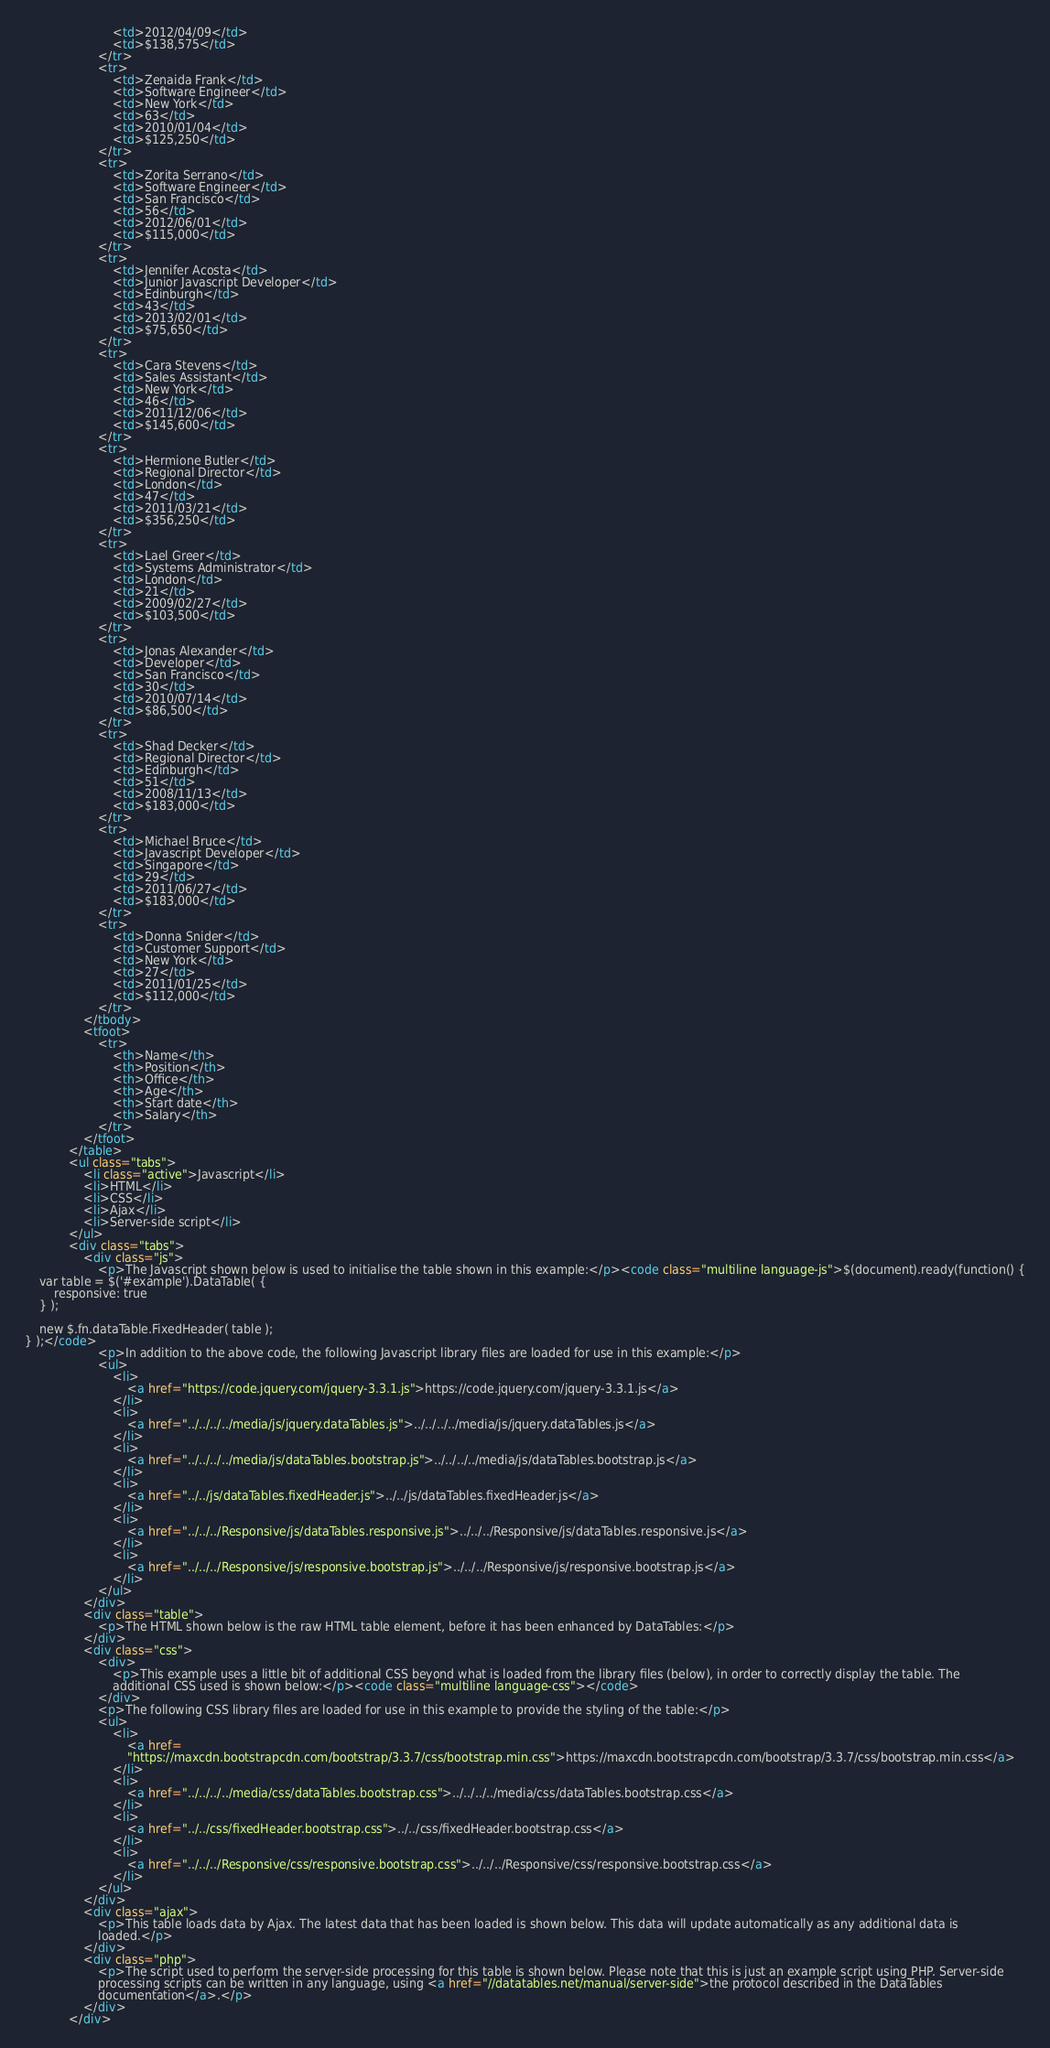<code> <loc_0><loc_0><loc_500><loc_500><_HTML_>						<td>2012/04/09</td>
						<td>$138,575</td>
					</tr>
					<tr>
						<td>Zenaida Frank</td>
						<td>Software Engineer</td>
						<td>New York</td>
						<td>63</td>
						<td>2010/01/04</td>
						<td>$125,250</td>
					</tr>
					<tr>
						<td>Zorita Serrano</td>
						<td>Software Engineer</td>
						<td>San Francisco</td>
						<td>56</td>
						<td>2012/06/01</td>
						<td>$115,000</td>
					</tr>
					<tr>
						<td>Jennifer Acosta</td>
						<td>Junior Javascript Developer</td>
						<td>Edinburgh</td>
						<td>43</td>
						<td>2013/02/01</td>
						<td>$75,650</td>
					</tr>
					<tr>
						<td>Cara Stevens</td>
						<td>Sales Assistant</td>
						<td>New York</td>
						<td>46</td>
						<td>2011/12/06</td>
						<td>$145,600</td>
					</tr>
					<tr>
						<td>Hermione Butler</td>
						<td>Regional Director</td>
						<td>London</td>
						<td>47</td>
						<td>2011/03/21</td>
						<td>$356,250</td>
					</tr>
					<tr>
						<td>Lael Greer</td>
						<td>Systems Administrator</td>
						<td>London</td>
						<td>21</td>
						<td>2009/02/27</td>
						<td>$103,500</td>
					</tr>
					<tr>
						<td>Jonas Alexander</td>
						<td>Developer</td>
						<td>San Francisco</td>
						<td>30</td>
						<td>2010/07/14</td>
						<td>$86,500</td>
					</tr>
					<tr>
						<td>Shad Decker</td>
						<td>Regional Director</td>
						<td>Edinburgh</td>
						<td>51</td>
						<td>2008/11/13</td>
						<td>$183,000</td>
					</tr>
					<tr>
						<td>Michael Bruce</td>
						<td>Javascript Developer</td>
						<td>Singapore</td>
						<td>29</td>
						<td>2011/06/27</td>
						<td>$183,000</td>
					</tr>
					<tr>
						<td>Donna Snider</td>
						<td>Customer Support</td>
						<td>New York</td>
						<td>27</td>
						<td>2011/01/25</td>
						<td>$112,000</td>
					</tr>
				</tbody>
				<tfoot>
					<tr>
						<th>Name</th>
						<th>Position</th>
						<th>Office</th>
						<th>Age</th>
						<th>Start date</th>
						<th>Salary</th>
					</tr>
				</tfoot>
			</table>
			<ul class="tabs">
				<li class="active">Javascript</li>
				<li>HTML</li>
				<li>CSS</li>
				<li>Ajax</li>
				<li>Server-side script</li>
			</ul>
			<div class="tabs">
				<div class="js">
					<p>The Javascript shown below is used to initialise the table shown in this example:</p><code class="multiline language-js">$(document).ready(function() {
	var table = $('#example').DataTable( {
		responsive: true
	} );

	new $.fn.dataTable.FixedHeader( table );
} );</code>
					<p>In addition to the above code, the following Javascript library files are loaded for use in this example:</p>
					<ul>
						<li>
							<a href="https://code.jquery.com/jquery-3.3.1.js">https://code.jquery.com/jquery-3.3.1.js</a>
						</li>
						<li>
							<a href="../../../../media/js/jquery.dataTables.js">../../../../media/js/jquery.dataTables.js</a>
						</li>
						<li>
							<a href="../../../../media/js/dataTables.bootstrap.js">../../../../media/js/dataTables.bootstrap.js</a>
						</li>
						<li>
							<a href="../../js/dataTables.fixedHeader.js">../../js/dataTables.fixedHeader.js</a>
						</li>
						<li>
							<a href="../../../Responsive/js/dataTables.responsive.js">../../../Responsive/js/dataTables.responsive.js</a>
						</li>
						<li>
							<a href="../../../Responsive/js/responsive.bootstrap.js">../../../Responsive/js/responsive.bootstrap.js</a>
						</li>
					</ul>
				</div>
				<div class="table">
					<p>The HTML shown below is the raw HTML table element, before it has been enhanced by DataTables:</p>
				</div>
				<div class="css">
					<div>
						<p>This example uses a little bit of additional CSS beyond what is loaded from the library files (below), in order to correctly display the table. The
						additional CSS used is shown below:</p><code class="multiline language-css"></code>
					</div>
					<p>The following CSS library files are loaded for use in this example to provide the styling of the table:</p>
					<ul>
						<li>
							<a href=
							"https://maxcdn.bootstrapcdn.com/bootstrap/3.3.7/css/bootstrap.min.css">https://maxcdn.bootstrapcdn.com/bootstrap/3.3.7/css/bootstrap.min.css</a>
						</li>
						<li>
							<a href="../../../../media/css/dataTables.bootstrap.css">../../../../media/css/dataTables.bootstrap.css</a>
						</li>
						<li>
							<a href="../../css/fixedHeader.bootstrap.css">../../css/fixedHeader.bootstrap.css</a>
						</li>
						<li>
							<a href="../../../Responsive/css/responsive.bootstrap.css">../../../Responsive/css/responsive.bootstrap.css</a>
						</li>
					</ul>
				</div>
				<div class="ajax">
					<p>This table loads data by Ajax. The latest data that has been loaded is shown below. This data will update automatically as any additional data is
					loaded.</p>
				</div>
				<div class="php">
					<p>The script used to perform the server-side processing for this table is shown below. Please note that this is just an example script using PHP. Server-side
					processing scripts can be written in any language, using <a href="//datatables.net/manual/server-side">the protocol described in the DataTables
					documentation</a>.</p>
				</div>
			</div></code> 